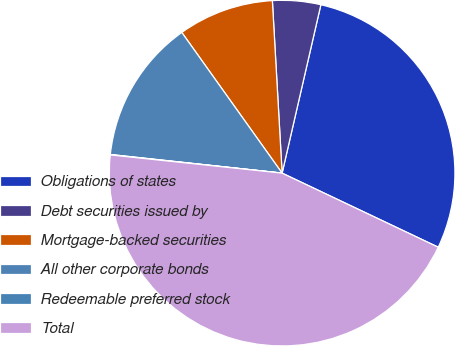<chart> <loc_0><loc_0><loc_500><loc_500><pie_chart><fcel>Obligations of states<fcel>Debt securities issued by<fcel>Mortgage-backed securities<fcel>All other corporate bonds<fcel>Redeemable preferred stock<fcel>Total<nl><fcel>28.45%<fcel>4.5%<fcel>8.96%<fcel>13.42%<fcel>0.04%<fcel>44.63%<nl></chart> 